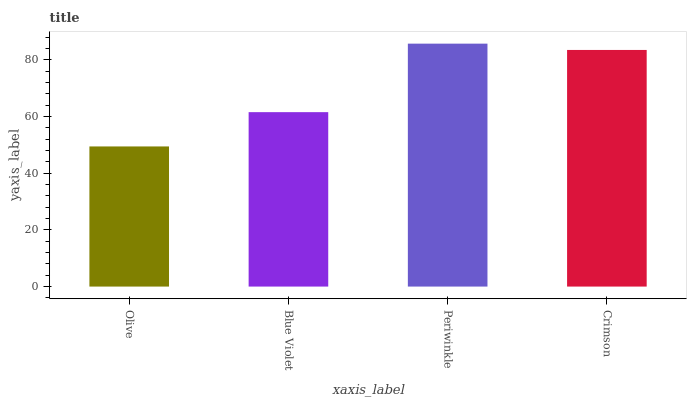Is Olive the minimum?
Answer yes or no. Yes. Is Periwinkle the maximum?
Answer yes or no. Yes. Is Blue Violet the minimum?
Answer yes or no. No. Is Blue Violet the maximum?
Answer yes or no. No. Is Blue Violet greater than Olive?
Answer yes or no. Yes. Is Olive less than Blue Violet?
Answer yes or no. Yes. Is Olive greater than Blue Violet?
Answer yes or no. No. Is Blue Violet less than Olive?
Answer yes or no. No. Is Crimson the high median?
Answer yes or no. Yes. Is Blue Violet the low median?
Answer yes or no. Yes. Is Periwinkle the high median?
Answer yes or no. No. Is Crimson the low median?
Answer yes or no. No. 